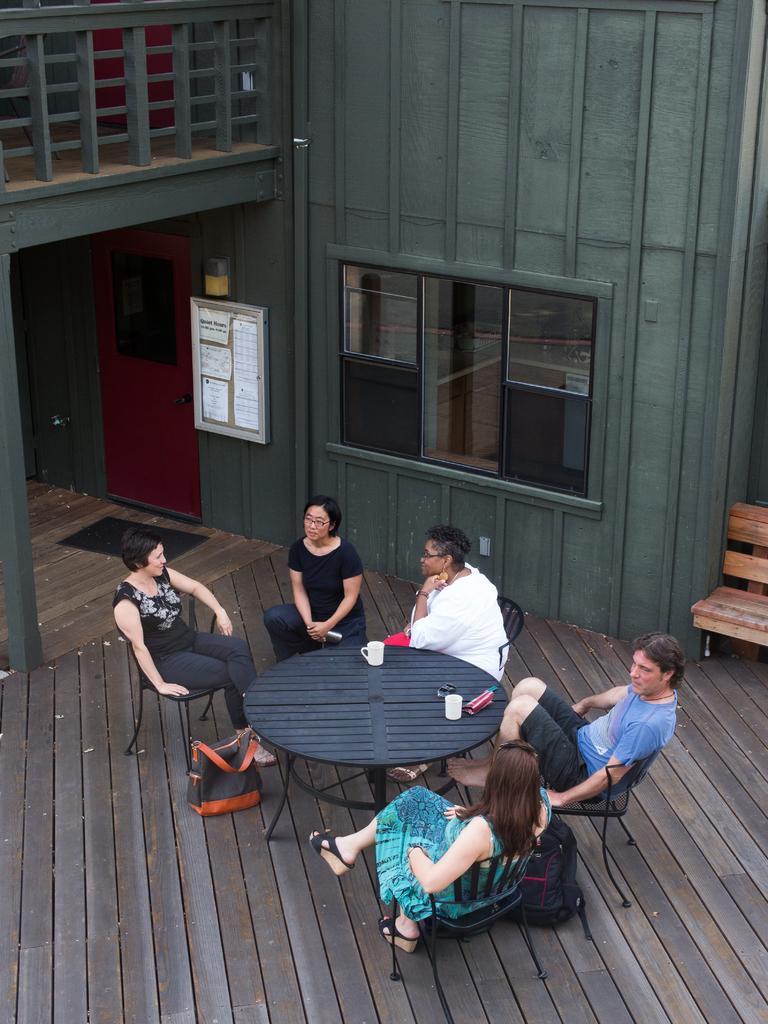Describe this image in one or two sentences. In this image we can see few people sitting on chairs. In the middle we can see few objects on a table. Behind the persons we can see a building. On the building we can see windows, a door and a board. On the board there are few papers. On the right side, we can see a bench. At the top we can see a fencing. 